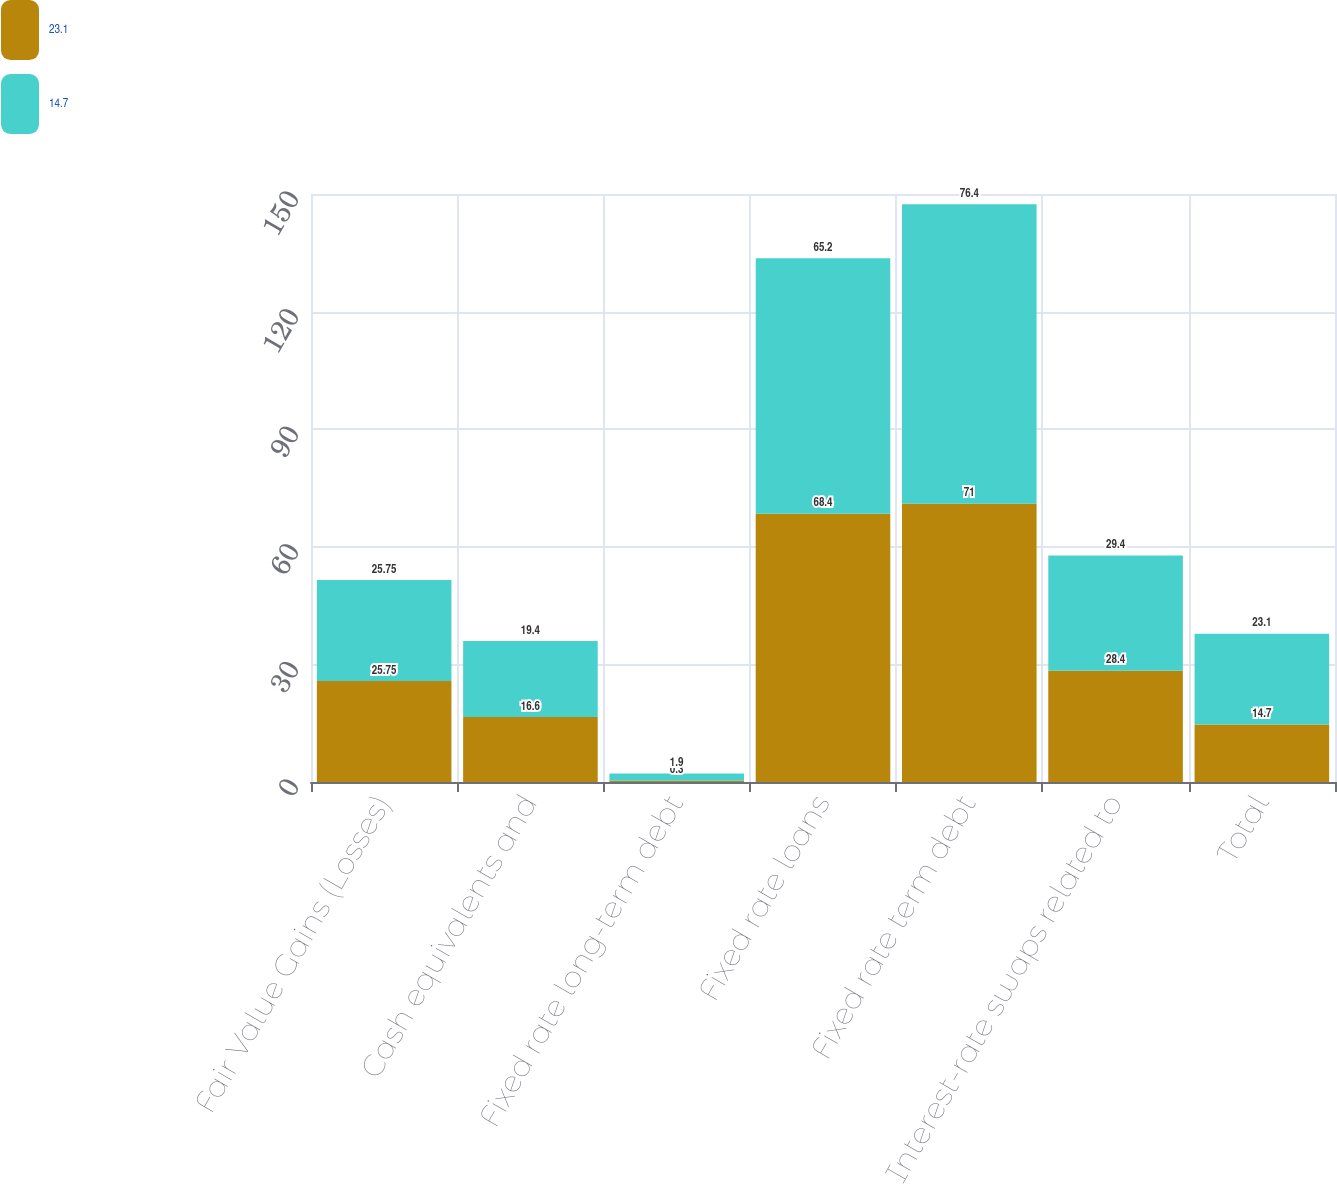Convert chart. <chart><loc_0><loc_0><loc_500><loc_500><stacked_bar_chart><ecel><fcel>Fair Value Gains (Losses)<fcel>Cash equivalents and<fcel>Fixed rate long-term debt<fcel>Fixed rate loans<fcel>Fixed rate term debt<fcel>Interest-rate swaps related to<fcel>Total<nl><fcel>23.1<fcel>25.75<fcel>16.6<fcel>0.3<fcel>68.4<fcel>71<fcel>28.4<fcel>14.7<nl><fcel>14.7<fcel>25.75<fcel>19.4<fcel>1.9<fcel>65.2<fcel>76.4<fcel>29.4<fcel>23.1<nl></chart> 